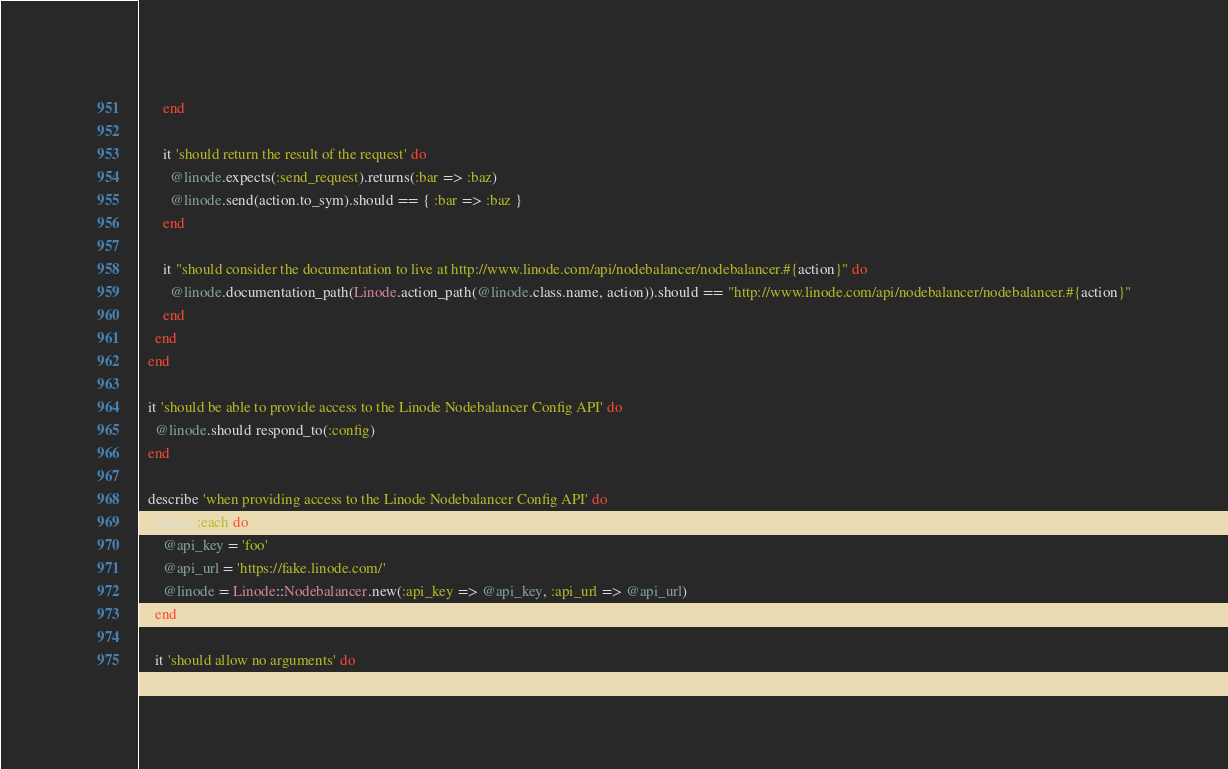<code> <loc_0><loc_0><loc_500><loc_500><_Ruby_>      end
    
      it 'should return the result of the request' do
        @linode.expects(:send_request).returns(:bar => :baz)      
        @linode.send(action.to_sym).should == { :bar => :baz }      
      end
      
      it "should consider the documentation to live at http://www.linode.com/api/nodebalancer/nodebalancer.#{action}" do
        @linode.documentation_path(Linode.action_path(@linode.class.name, action)).should == "http://www.linode.com/api/nodebalancer/nodebalancer.#{action}"
      end
    end
  end
  
  it 'should be able to provide access to the Linode Nodebalancer Config API' do
    @linode.should respond_to(:config)
  end
  
  describe 'when providing access to the Linode Nodebalancer Config API' do
    before :each do
      @api_key = 'foo'
      @api_url = 'https://fake.linode.com/'
      @linode = Linode::Nodebalancer.new(:api_key => @api_key, :api_url => @api_url)
    end

    it 'should allow no arguments' do</code> 